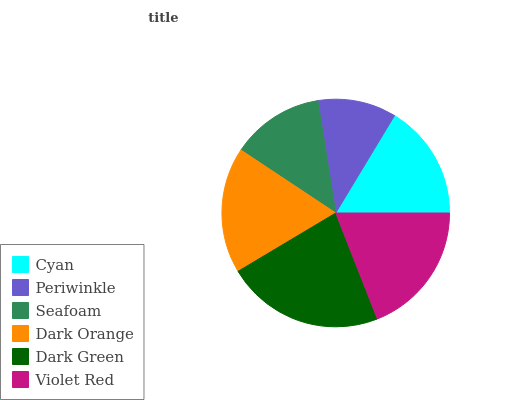Is Periwinkle the minimum?
Answer yes or no. Yes. Is Dark Green the maximum?
Answer yes or no. Yes. Is Seafoam the minimum?
Answer yes or no. No. Is Seafoam the maximum?
Answer yes or no. No. Is Seafoam greater than Periwinkle?
Answer yes or no. Yes. Is Periwinkle less than Seafoam?
Answer yes or no. Yes. Is Periwinkle greater than Seafoam?
Answer yes or no. No. Is Seafoam less than Periwinkle?
Answer yes or no. No. Is Dark Orange the high median?
Answer yes or no. Yes. Is Cyan the low median?
Answer yes or no. Yes. Is Periwinkle the high median?
Answer yes or no. No. Is Periwinkle the low median?
Answer yes or no. No. 